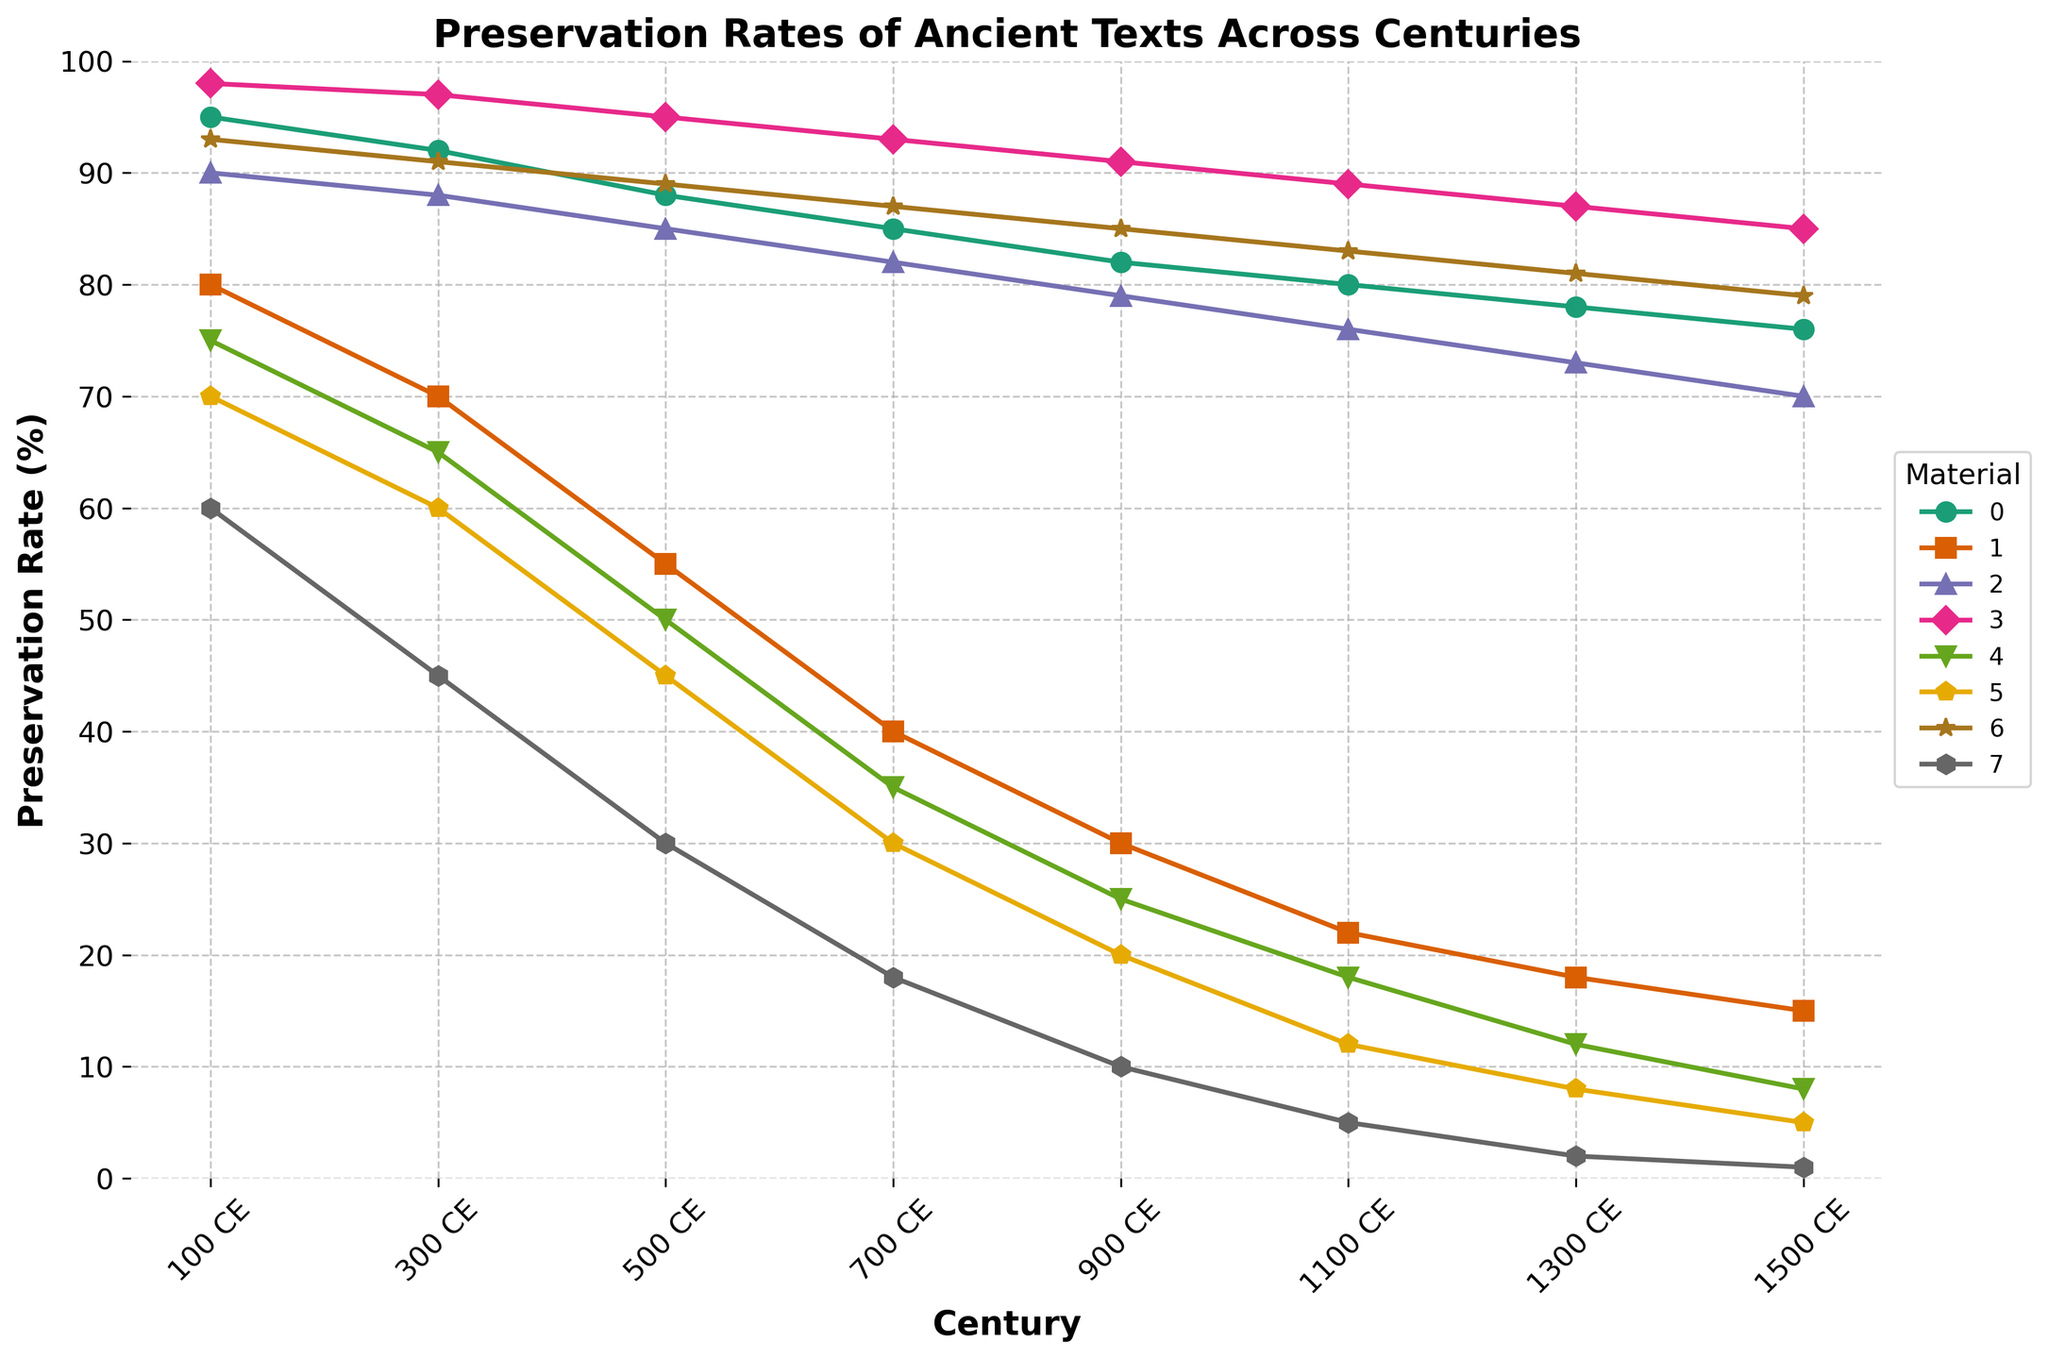Which material shows the highest preservation rate across all centuries? To find the material with the highest preservation rate, look at the top-most line. The line representing "Stone inscriptions" consistently stays at the highest position on the y-axis across all centuries.
Answer: Stone inscriptions Which materials have a preservation rate below 20% in the year 1500 CE? Identify the data points for each material in the year 1500 CE. The materials with preservation rates below 20% in that year are "Wax tablets" (1%), "Palm leaf manuscripts" (5%), "Bamboo slips" (8%), and "Papyrus scrolls" (15%).
Answer: Wax tablets, Palm leaf manuscripts, Bamboo slips, Papyrus scrolls How does the preservation rate of Clay tablets change from 100 CE to 900 CE? Observe the line for Clay tablets and note the preservation rates at 100 CE (95%) and 900 CE (82%). The rate decreased by 13 percentage points over 800 years.
Answer: Decreases by 13% Which materials show a steady decline in preservation rate over the centuries? Look at the lines that continuously decrease without any plateaus or increases. "Clay tablets," "Papyrus scrolls," "Parchment," "Stone inscriptions," "Bamboo slips," "Palm leaf manuscripts," "Metal plates," and "Wax tablets" all show a steady decline.
Answer: Clay tablets, Papyrus scrolls, Parchment, Stone inscriptions, Bamboo slips, Palm leaf manuscripts, Metal plates, Wax tablets What's the average preservation rate of Metal plates across the centuries shown? Calculate the average of the preservation rates: (93 + 91 + 89 + 87 + 85 + 83 + 81 + 79) / 8 = 85.875%
Answer: 85.875% In which century does Parchment have the same preservation rate as Metal plates? Identify the points where the lines for Parchment and Metal plates intersect. They intersect in the year 300 CE at a preservation rate of 88%.
Answer: 300 CE Comparing 1300 CE, which material showed a larger decline in preservation rate since 100 CE: Papyrus scrolls or Palm leaf manuscripts? Calculate the decline for each: Papyrus scrolls (80% - 18% = 62%), Palm leaf manuscripts (70% - 8% = 62%). Both materials show a decline of 62%.
Answer: Both declined by 62% Which material experienced the fastest decline in preservation rate between 500 CE and 700 CE? Calculate the difference in preservation rates for each material between 500 CE and 700 CE, then find the material with the largest difference. Wax tablets show the fastest decline (30% - 18% = 12%).
Answer: Wax tablets How does the preservation rate of Parchment compare to that of Papyrus scrolls in 1100 CE? Compare the preservation rates in 1100 CE. Parchment (76%) is significantly higher than Papyrus scrolls (22%).
Answer: Parchment is higher What is the median preservation rate for Bamboo slips across all centuries? Arrange the rates of Bamboo slips in ascending order: 8, 12, 18, 25, 35, 50, 65, 75. The median is the average of the middle two values: (25 + 35) / 2 = 30%.
Answer: 30% 